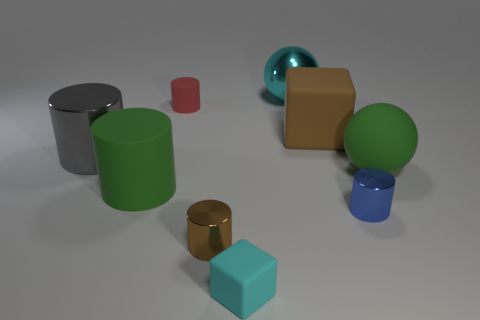There is a big sphere that is the same color as the large matte cylinder; what is it made of?
Your answer should be very brief. Rubber. What shape is the object that is the same color as the shiny sphere?
Offer a terse response. Cube. There is a brown thing that is on the right side of the large cyan metal object; what number of big cyan shiny objects are in front of it?
Keep it short and to the point. 0. Is the number of brown metal cylinders that are behind the cyan shiny ball less than the number of brown metal cylinders to the left of the red cylinder?
Keep it short and to the point. No. What is the shape of the metallic thing that is to the left of the small cylinder behind the big gray shiny cylinder?
Offer a very short reply. Cylinder. How many other objects are the same material as the red object?
Give a very brief answer. 4. Is there anything else that is the same size as the cyan shiny object?
Your answer should be compact. Yes. Are there more large blocks than large metal objects?
Give a very brief answer. No. There is a rubber sphere that is on the right side of the brown thing in front of the gray object that is in front of the tiny rubber cylinder; how big is it?
Keep it short and to the point. Large. There is a red matte object; does it have the same size as the block that is to the left of the big block?
Provide a short and direct response. Yes. 